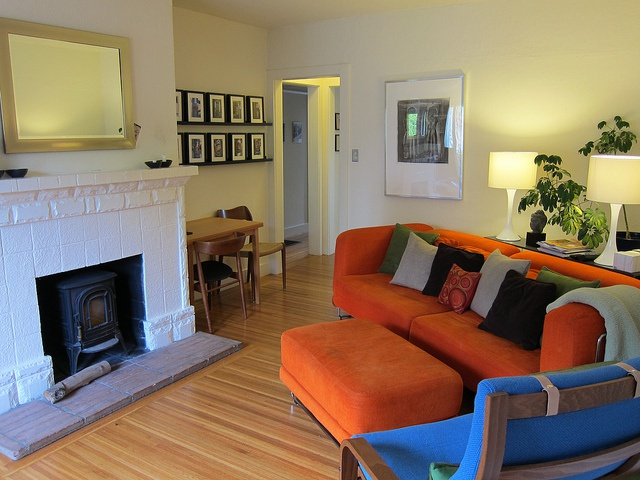Describe the objects in this image and their specific colors. I can see couch in darkgray, navy, maroon, gray, and blue tones, chair in darkgray, navy, maroon, and blue tones, couch in darkgray, brown, maroon, and red tones, tv in darkgray, tan, olive, and khaki tones, and potted plant in darkgray, black, olive, and darkgreen tones in this image. 